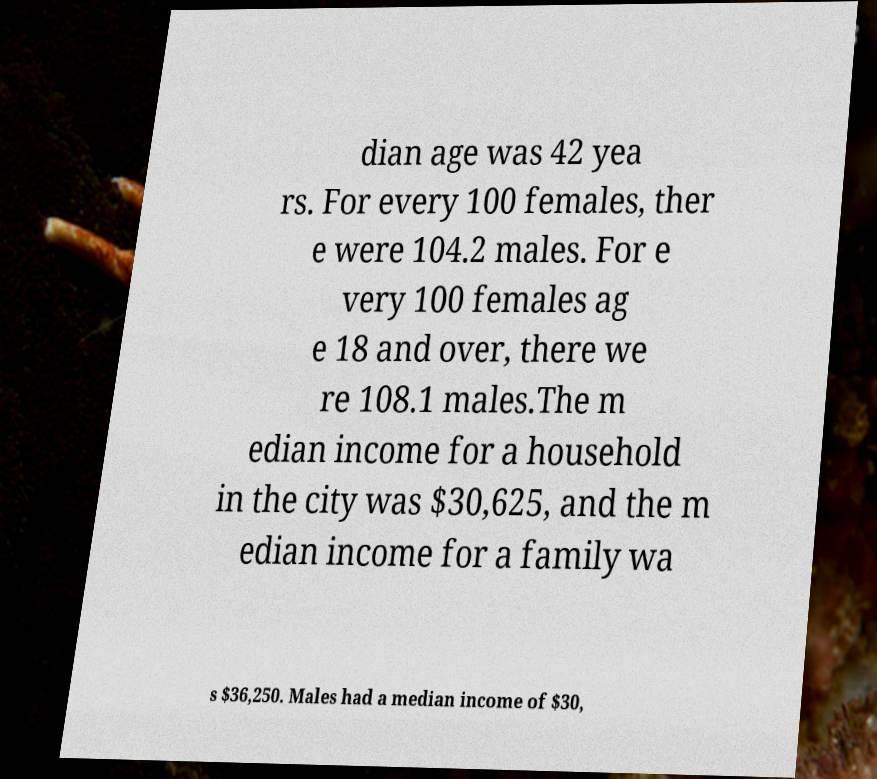Could you extract and type out the text from this image? dian age was 42 yea rs. For every 100 females, ther e were 104.2 males. For e very 100 females ag e 18 and over, there we re 108.1 males.The m edian income for a household in the city was $30,625, and the m edian income for a family wa s $36,250. Males had a median income of $30, 